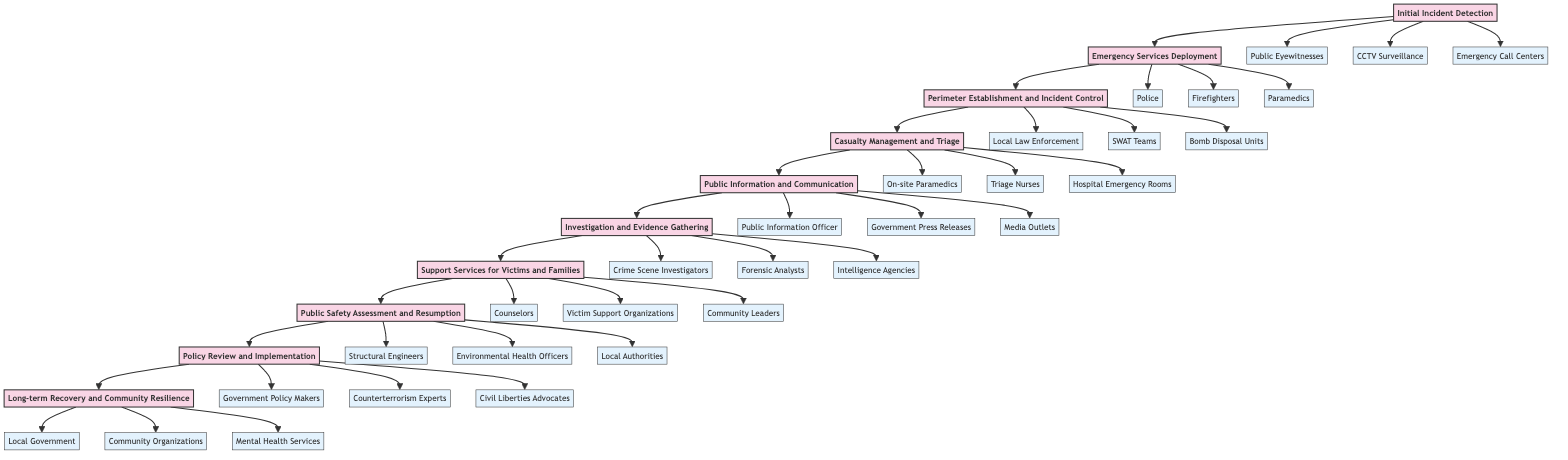What is the first stage in the incident response timeline? The diagram lists the stages sequentially, starting with "Initial Incident Detection" as the first stage.
Answer: Initial Incident Detection How many entities are associated with the "Emergency Services Deployment" stage? In the diagram, "Emergency Services Deployment" is linked to three entities: Police, Firefighters, and Paramedics. Counting these entities gives a total of three.
Answer: Three Which stage directly follows "Public Information and Communication"? The flowchart shows arrows indicating the flow from "Public Information and Communication" to the next stage, which is "Investigation and Evidence Gathering." Therefore, the next stage is "Investigation and Evidence Gathering."
Answer: Investigation and Evidence Gathering What is the last stage in the incident response timeline? The diagram's sequence culminates at the last stage, which is "Long-term Recovery and Community Resilience." This can be affirmed by reviewing the final node in the flowchart.
Answer: Long-term Recovery and Community Resilience Who is responsible for "Casualty Management and Triage"? The stage of "Casualty Management and Triage" is supported by three entities: On-site Paramedics, Triage Nurses, and Hospital Emergency Rooms, indicating that the responsibility falls on these groups.
Answer: On-site Paramedics, Triage Nurses, Hospital Emergency Rooms Describe the relationship between "Investigation and Evidence Gathering" and "Support Services for Victims and Families." The diagram's flow connects "Investigation and Evidence Gathering" to "Support Services for Victims and Families" with a directional arrow, indicating that the investigation occurs before providing support services. This implies that the investigation should inform the support services offered.
Answer: Investigation occurs before support services Which entities are involved in the "Perimeter Establishment and Incident Control" stage? The stage "Perimeter Establishment and Incident Control" is associated with three entities: Local Law Enforcement, SWAT Teams, and Bomb Disposal Units, which are listed as responsible groups for this stage.
Answer: Local Law Enforcement, SWAT Teams, Bomb Disposal Units How many stages are involved in the incident response timeline? By counting the number of unique stages listed in the diagram, there are ten stages in total.
Answer: Ten What role do "Government Policy Makers" play in the timeline? In the diagram, "Government Policy Makers" are mentioned under the "Policy Review and Implementation" stage, indicating their role is to review incidents for informing future counterterrorism policies and practices.
Answer: Policy Review and Implementation 